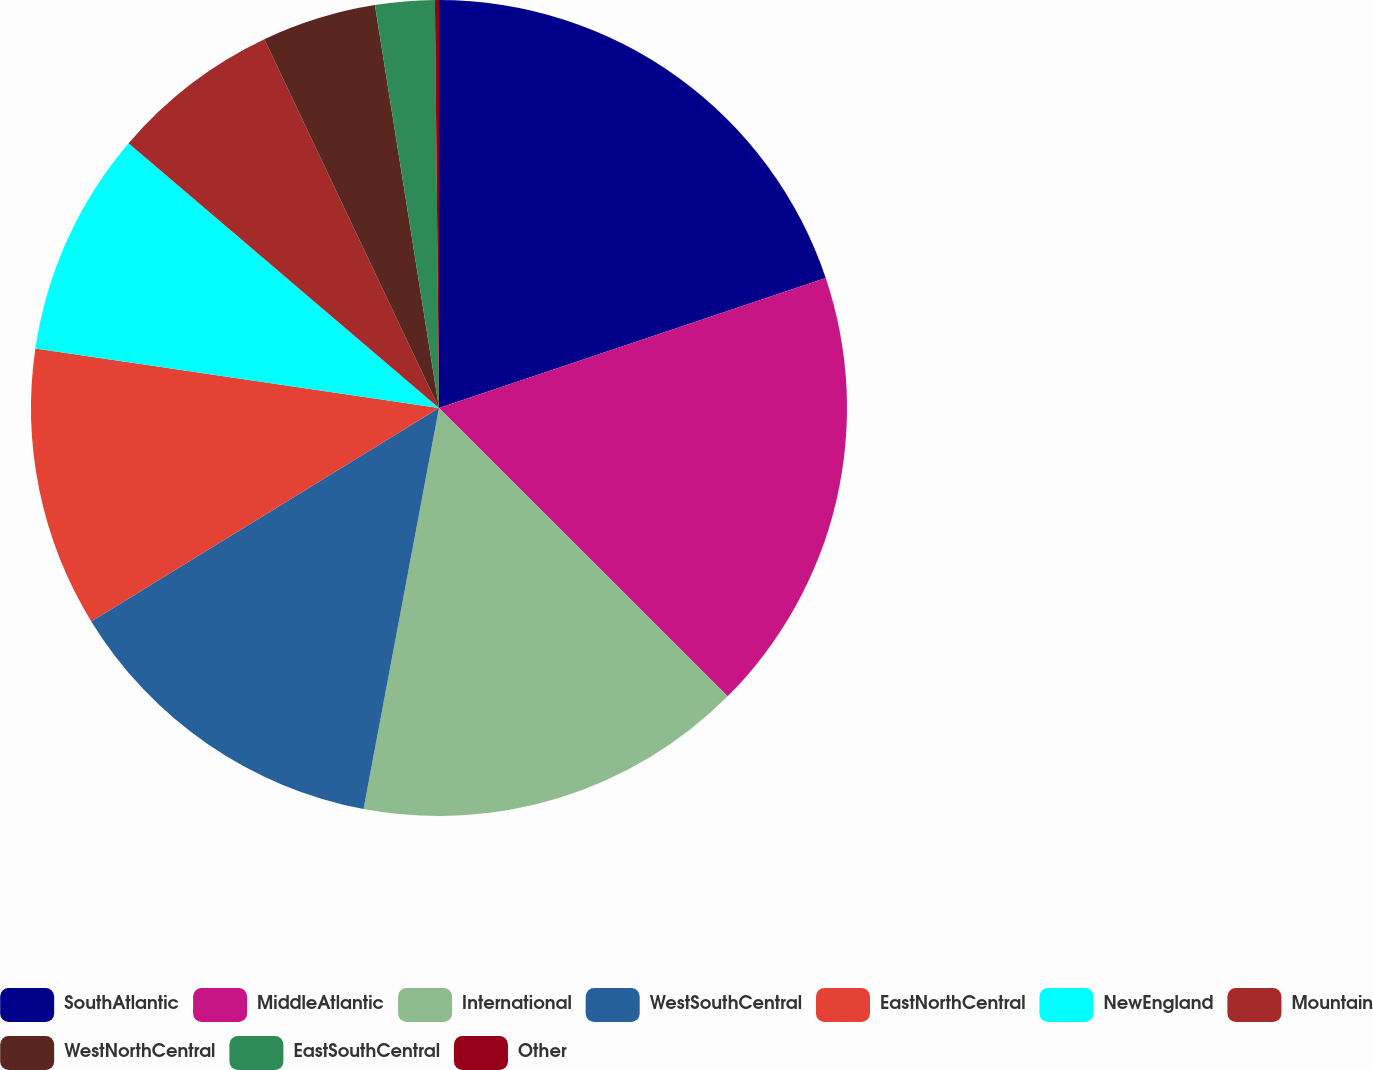Convert chart. <chart><loc_0><loc_0><loc_500><loc_500><pie_chart><fcel>SouthAtlantic<fcel>MiddleAtlantic<fcel>International<fcel>WestSouthCentral<fcel>EastNorthCentral<fcel>NewEngland<fcel>Mountain<fcel>WestNorthCentral<fcel>EastSouthCentral<fcel>Other<nl><fcel>19.84%<fcel>17.65%<fcel>15.47%<fcel>13.28%<fcel>11.09%<fcel>8.91%<fcel>6.72%<fcel>4.53%<fcel>2.35%<fcel>0.16%<nl></chart> 